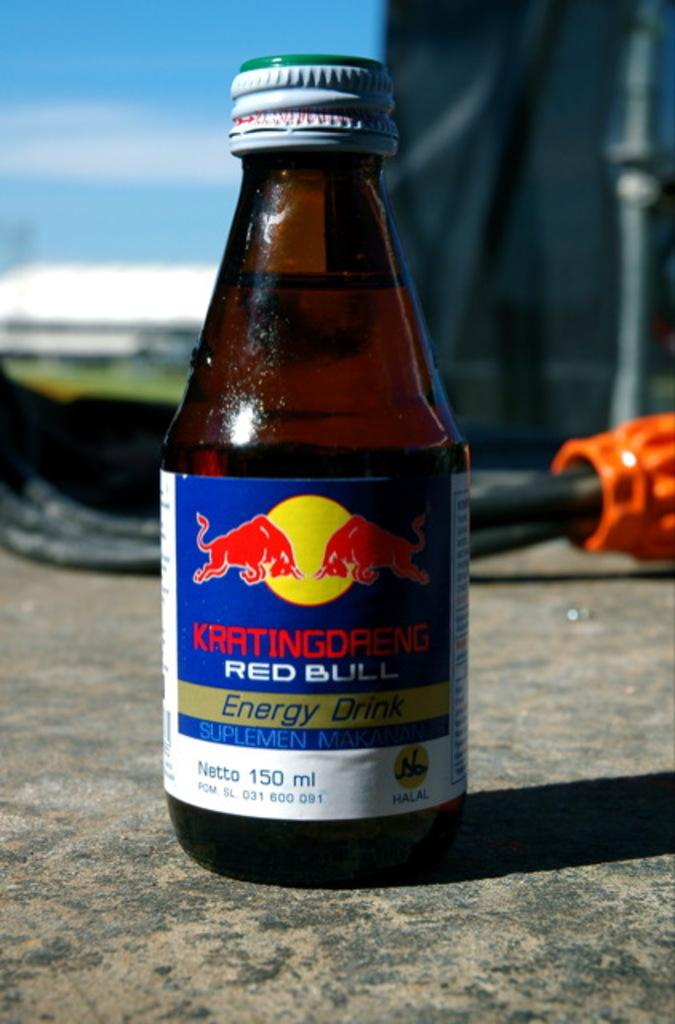<image>
Summarize the visual content of the image. Kratingdreng Red Bull Energy Drink Nietto 150 ml not opened. 